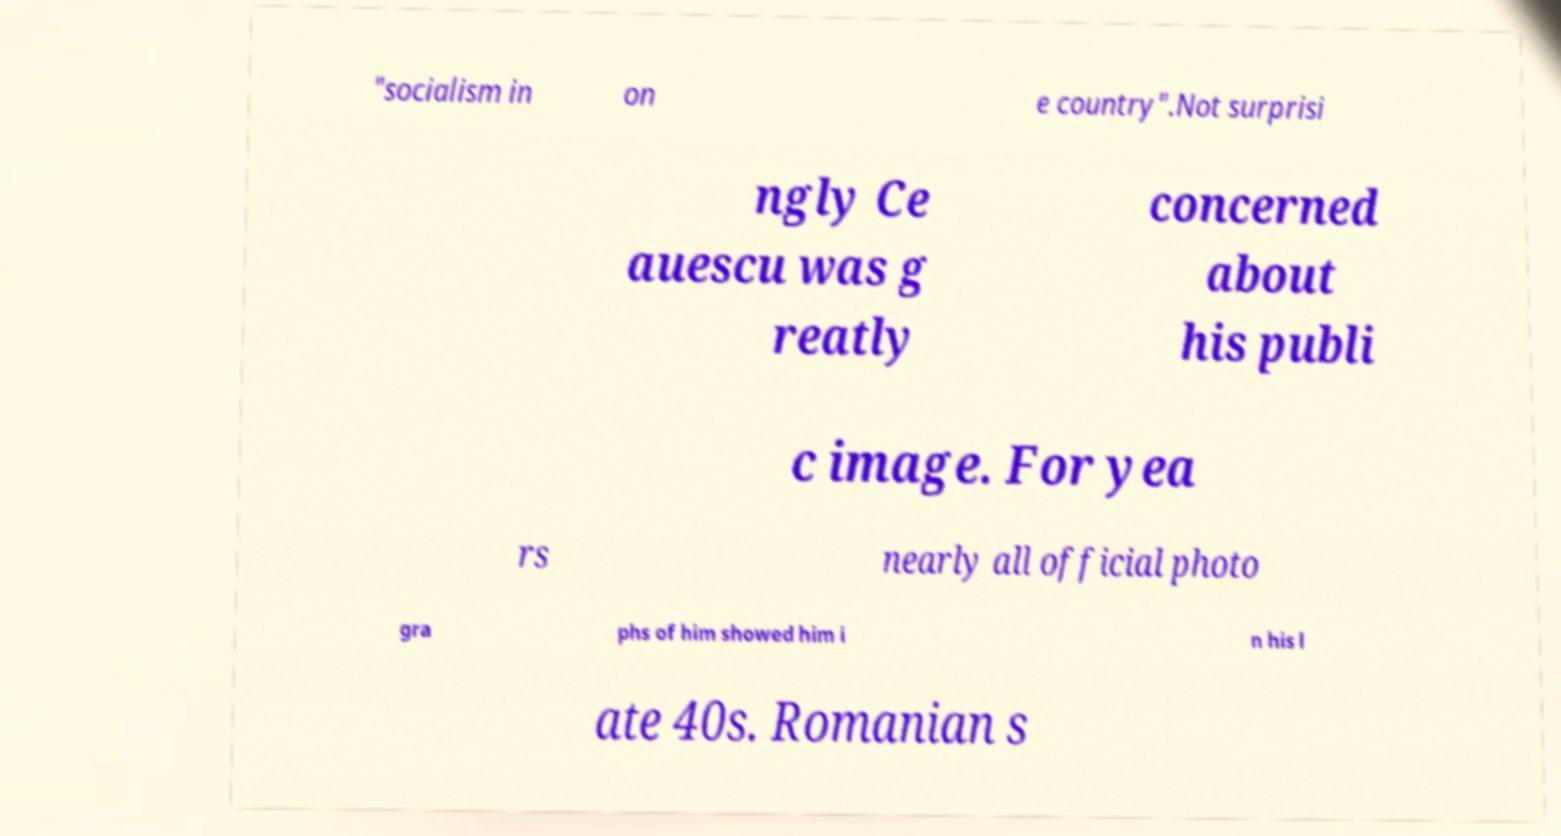Can you accurately transcribe the text from the provided image for me? "socialism in on e country".Not surprisi ngly Ce auescu was g reatly concerned about his publi c image. For yea rs nearly all official photo gra phs of him showed him i n his l ate 40s. Romanian s 